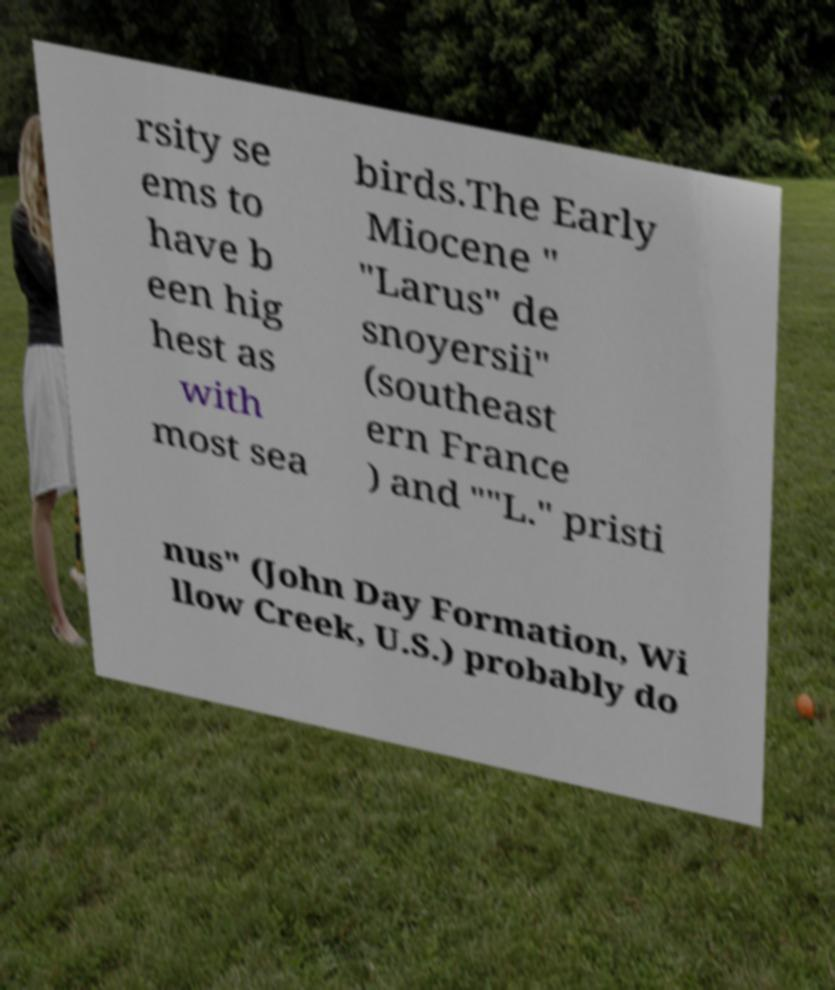Could you assist in decoding the text presented in this image and type it out clearly? rsity se ems to have b een hig hest as with most sea birds.The Early Miocene " "Larus" de snoyersii" (southeast ern France ) and ""L." pristi nus" (John Day Formation, Wi llow Creek, U.S.) probably do 